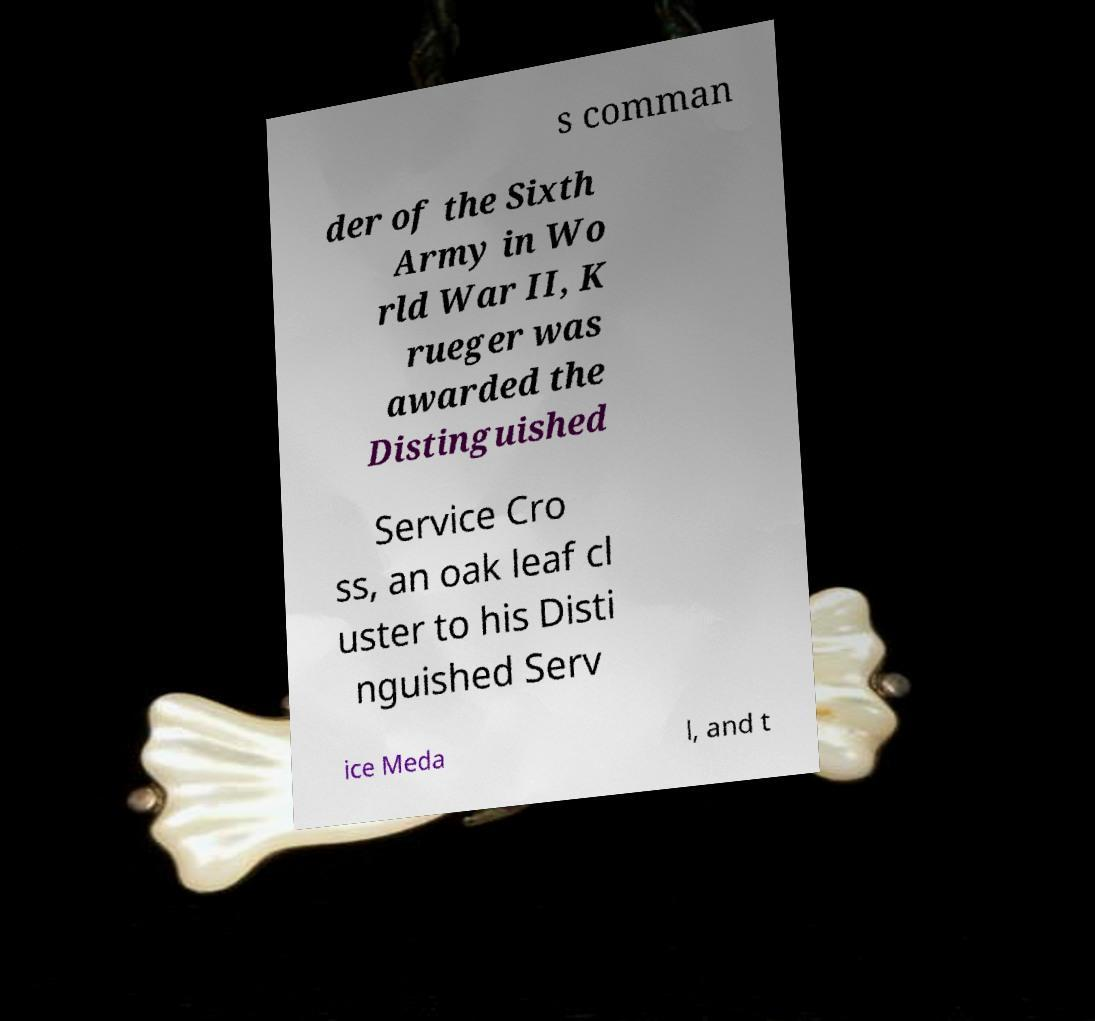What messages or text are displayed in this image? I need them in a readable, typed format. s comman der of the Sixth Army in Wo rld War II, K rueger was awarded the Distinguished Service Cro ss, an oak leaf cl uster to his Disti nguished Serv ice Meda l, and t 